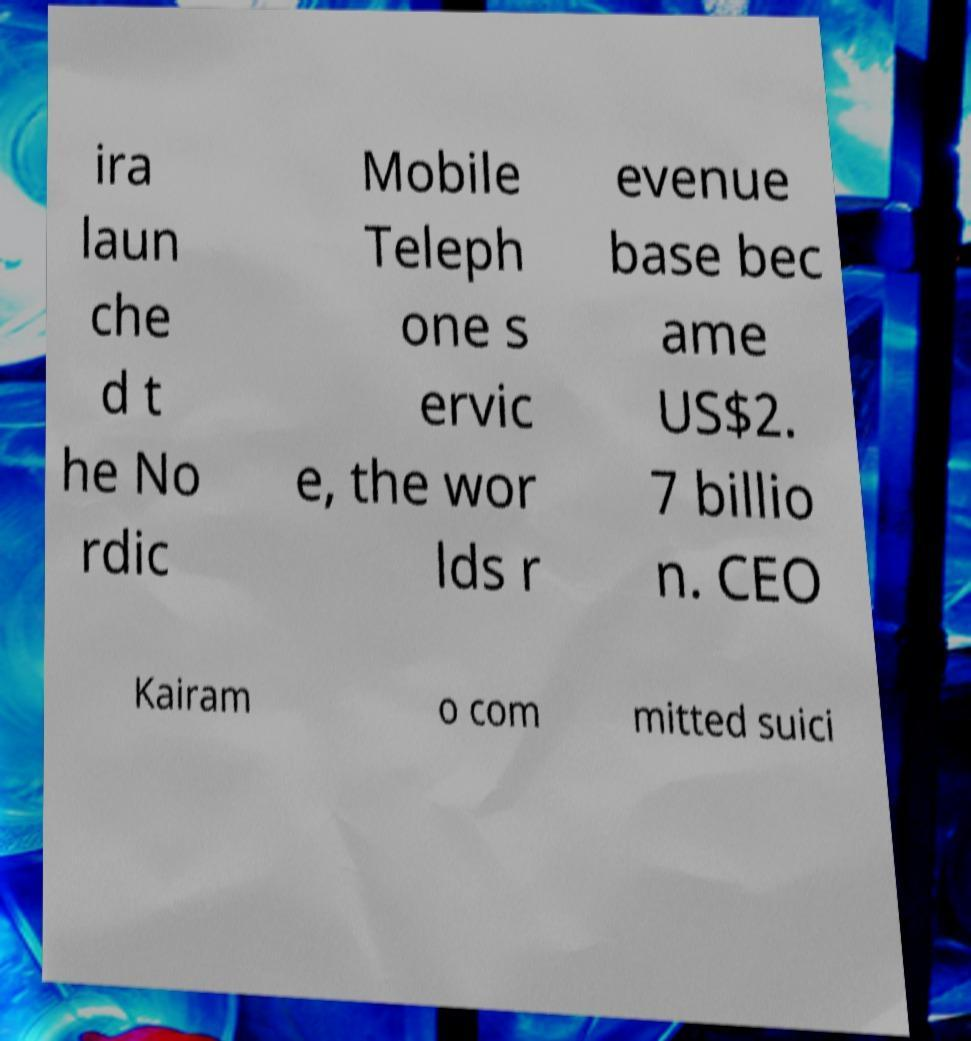Please identify and transcribe the text found in this image. ira laun che d t he No rdic Mobile Teleph one s ervic e, the wor lds r evenue base bec ame US$2. 7 billio n. CEO Kairam o com mitted suici 